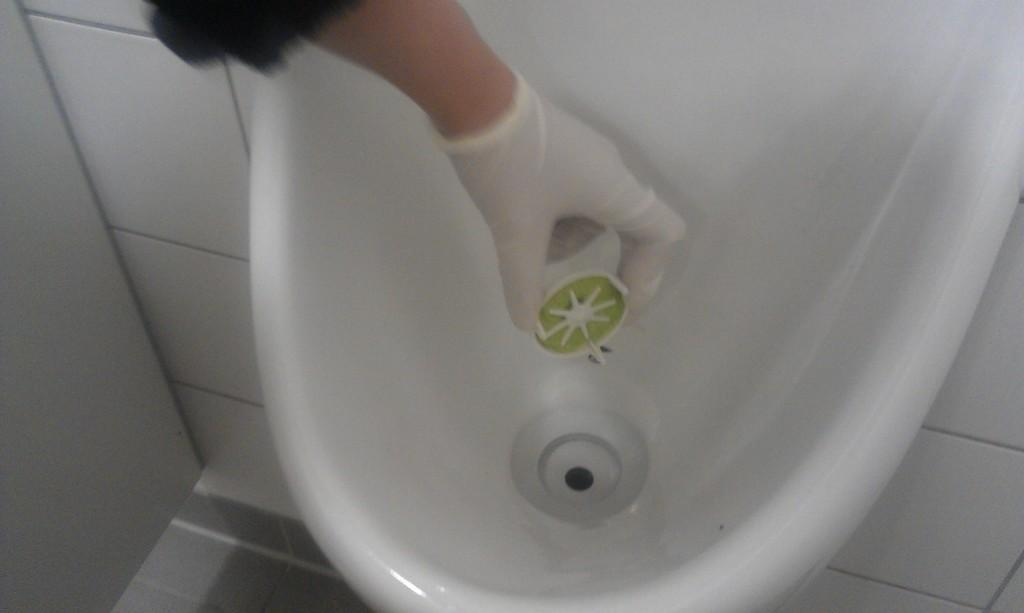What is the main object in the center of the image? There is a wash basin in the center of the image. Can you describe any human presence in the image? A person's hand is visible in the image. What is the person holding? The person is holding something, but the facts do not specify what it is. What can be seen in the background of the image? There is a wall in the background of the image. What chess move is the grandmother making in the image? There is no grandmother or chess scene present in the image. 